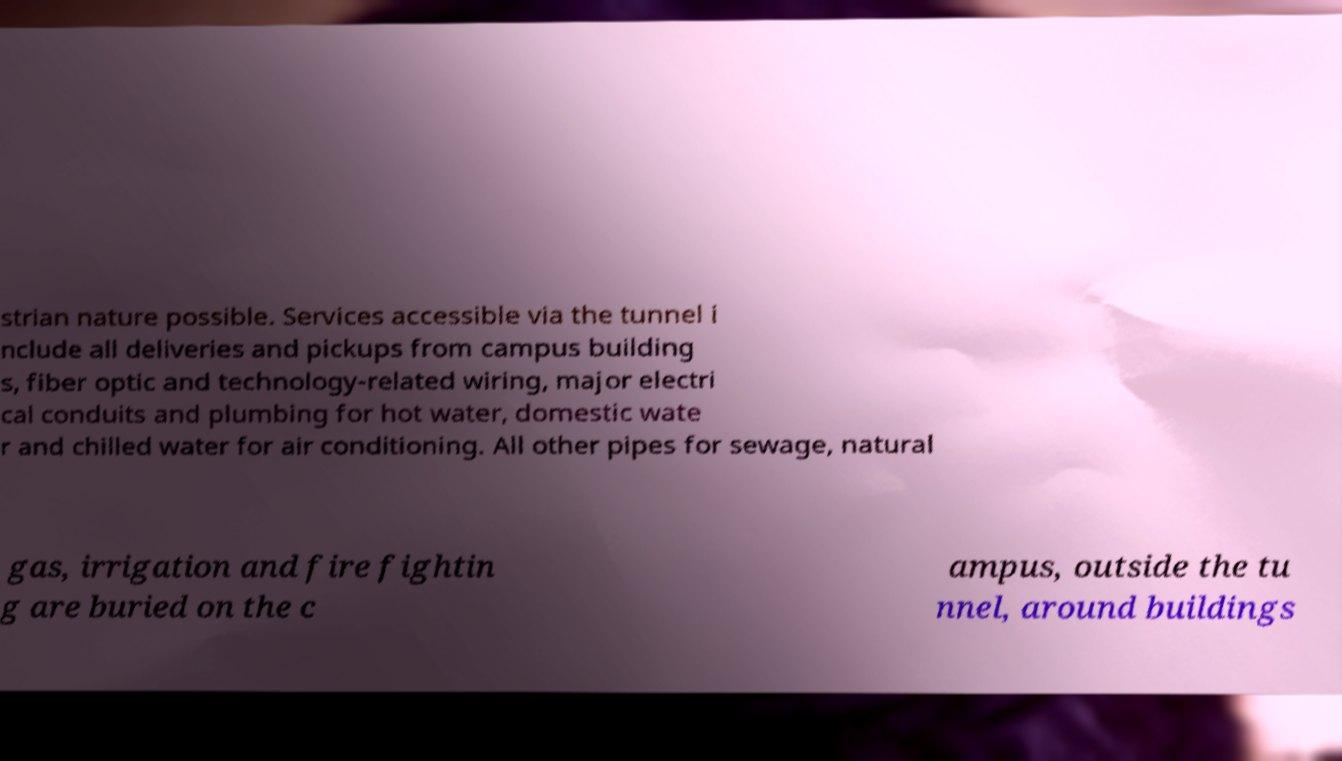There's text embedded in this image that I need extracted. Can you transcribe it verbatim? strian nature possible. Services accessible via the tunnel i nclude all deliveries and pickups from campus building s, fiber optic and technology-related wiring, major electri cal conduits and plumbing for hot water, domestic wate r and chilled water for air conditioning. All other pipes for sewage, natural gas, irrigation and fire fightin g are buried on the c ampus, outside the tu nnel, around buildings 